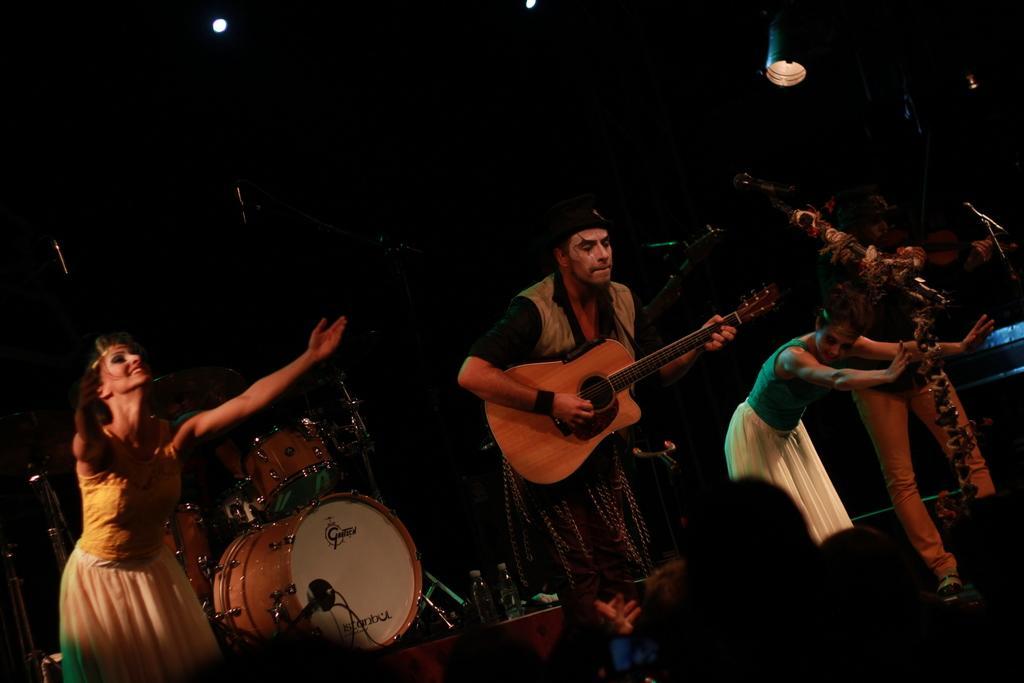Describe this image in one or two sentences. In the center of the image there is a man standing. He is playing a guitar. On the right there is a girl performing. On the left there is another girl. In the background there is a band, bottles and drums. 